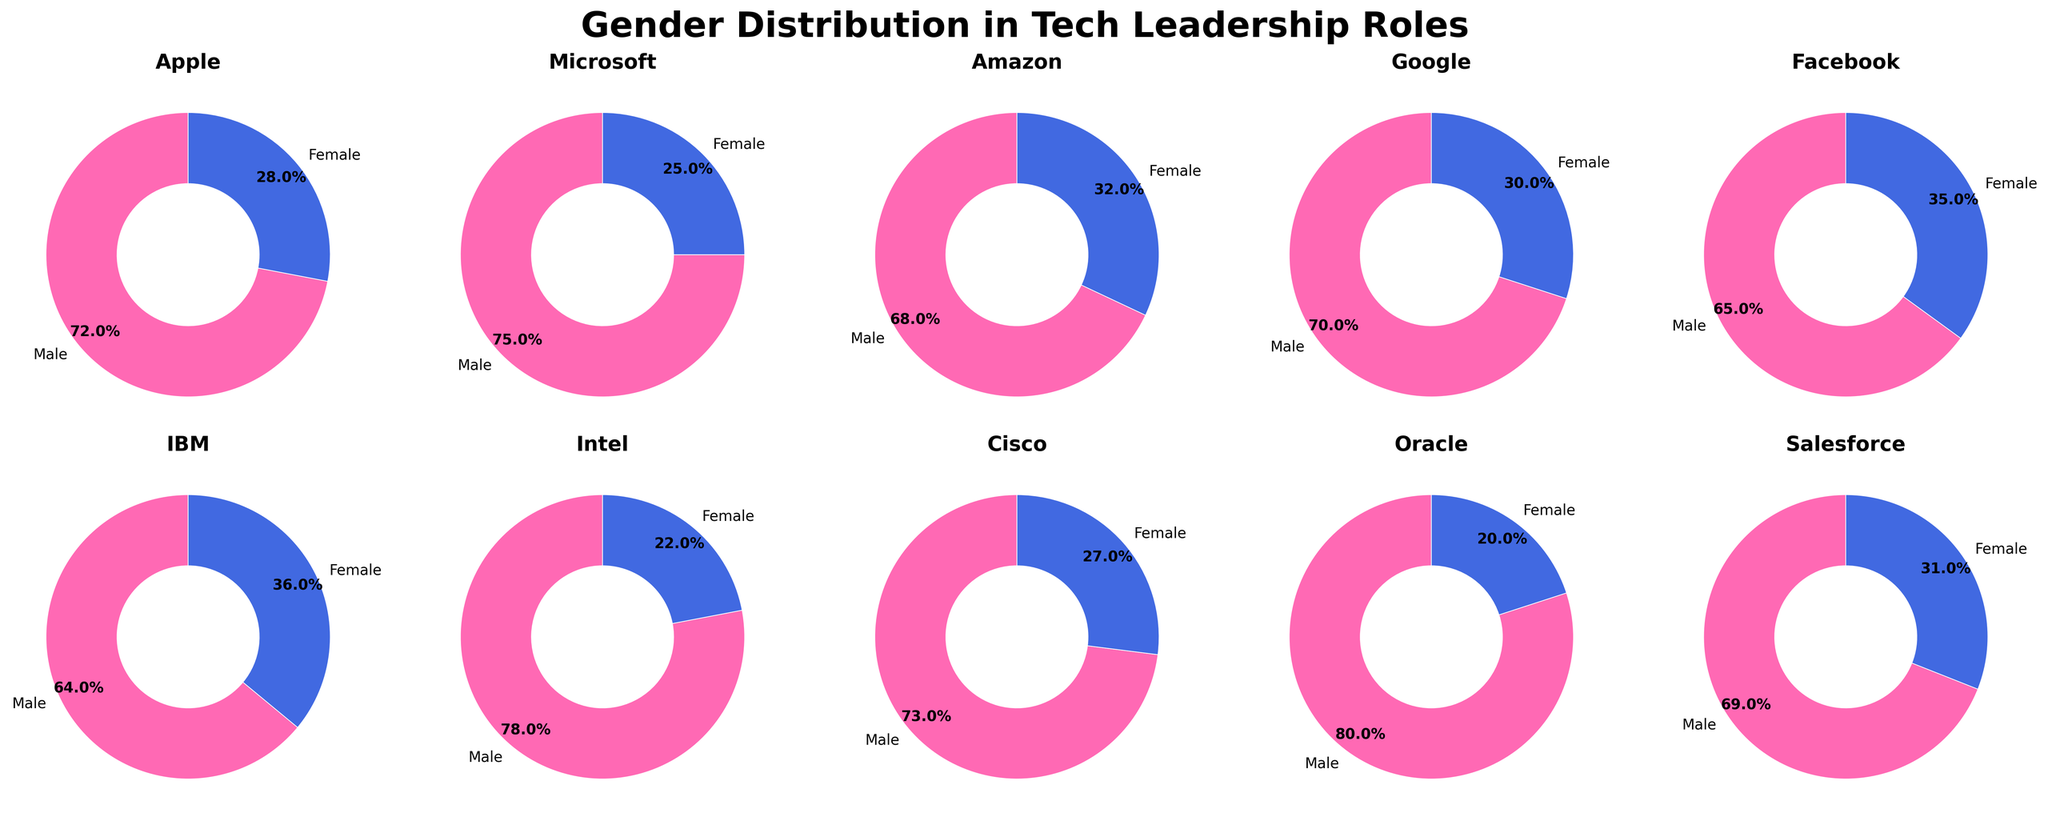What's the title of the figure? The title is usually displayed at the top of the figure. It is written in larger and bolder font to signify its importance.
Answer: Gender Distribution in Tech Leadership Roles Which company shows the highest percentage of female leadership? Look at the pie charts for each company and identify the chart with the largest slice representing female leadership.
Answer: IBM Which company has the lowest percentage of female leadership? Look at the pie charts for each company and find the chart with the smallest slice representing female leadership.
Answer: Oracle What is the average percentage of female leadership across all companies? Find the percentage of female leadership for each company, sum them up, and then divide by the number of companies. (28 + 25 + 32 + 30 + 35 + 36 + 22 + 27 + 20 + 31) / 10 = 28.6
Answer: 28.6% Which companies have a male leadership percentage greater than 70%? Identify which pie charts have more than 70% of the chart colored to represent male leadership. Check Apple, Microsoft, Intel, Cisco, and Oracle.
Answer: Apple, Microsoft, Intel, Cisco, Oracle How many companies have a female leadership percentage higher than the average? Calculate the average female leadership percentage, then count how many companies exceed this percentage. The average is 28.6%, and the companies exceeding this are Amazon, Facebook, IBM, Salesforce.
Answer: 4 Does any company have an exactly even gender distribution in leadership roles? Examine all pie charts to see if there’s any pair of slices that are of equal size.
Answer: No Among the given companies, which one shows the closest to an equal gender ratio in leadership roles? Identify the company where the slices representing male and female leadership are closest in size.
Answer: Facebook Compare Intel and IBM in terms of female leadership percentages. Which company has a higher percentage and by how much? Look at the pie charts for Intel and IBM and subtract Intel's female percentage from IBM's female percentage. IBM: 36%, Intel: 22%, Difference: 36 - 22 = 14.
Answer: IBM, by 14% Which company displays a more balanced gender distribution, Amazon or Google? Compare the size of the slices representing male and female leadership in both pie charts. Amazon shows 68% male and 32% female, while Google shows 70% male and 30% female. Amazon’s ratio is closer.
Answer: Amazon 